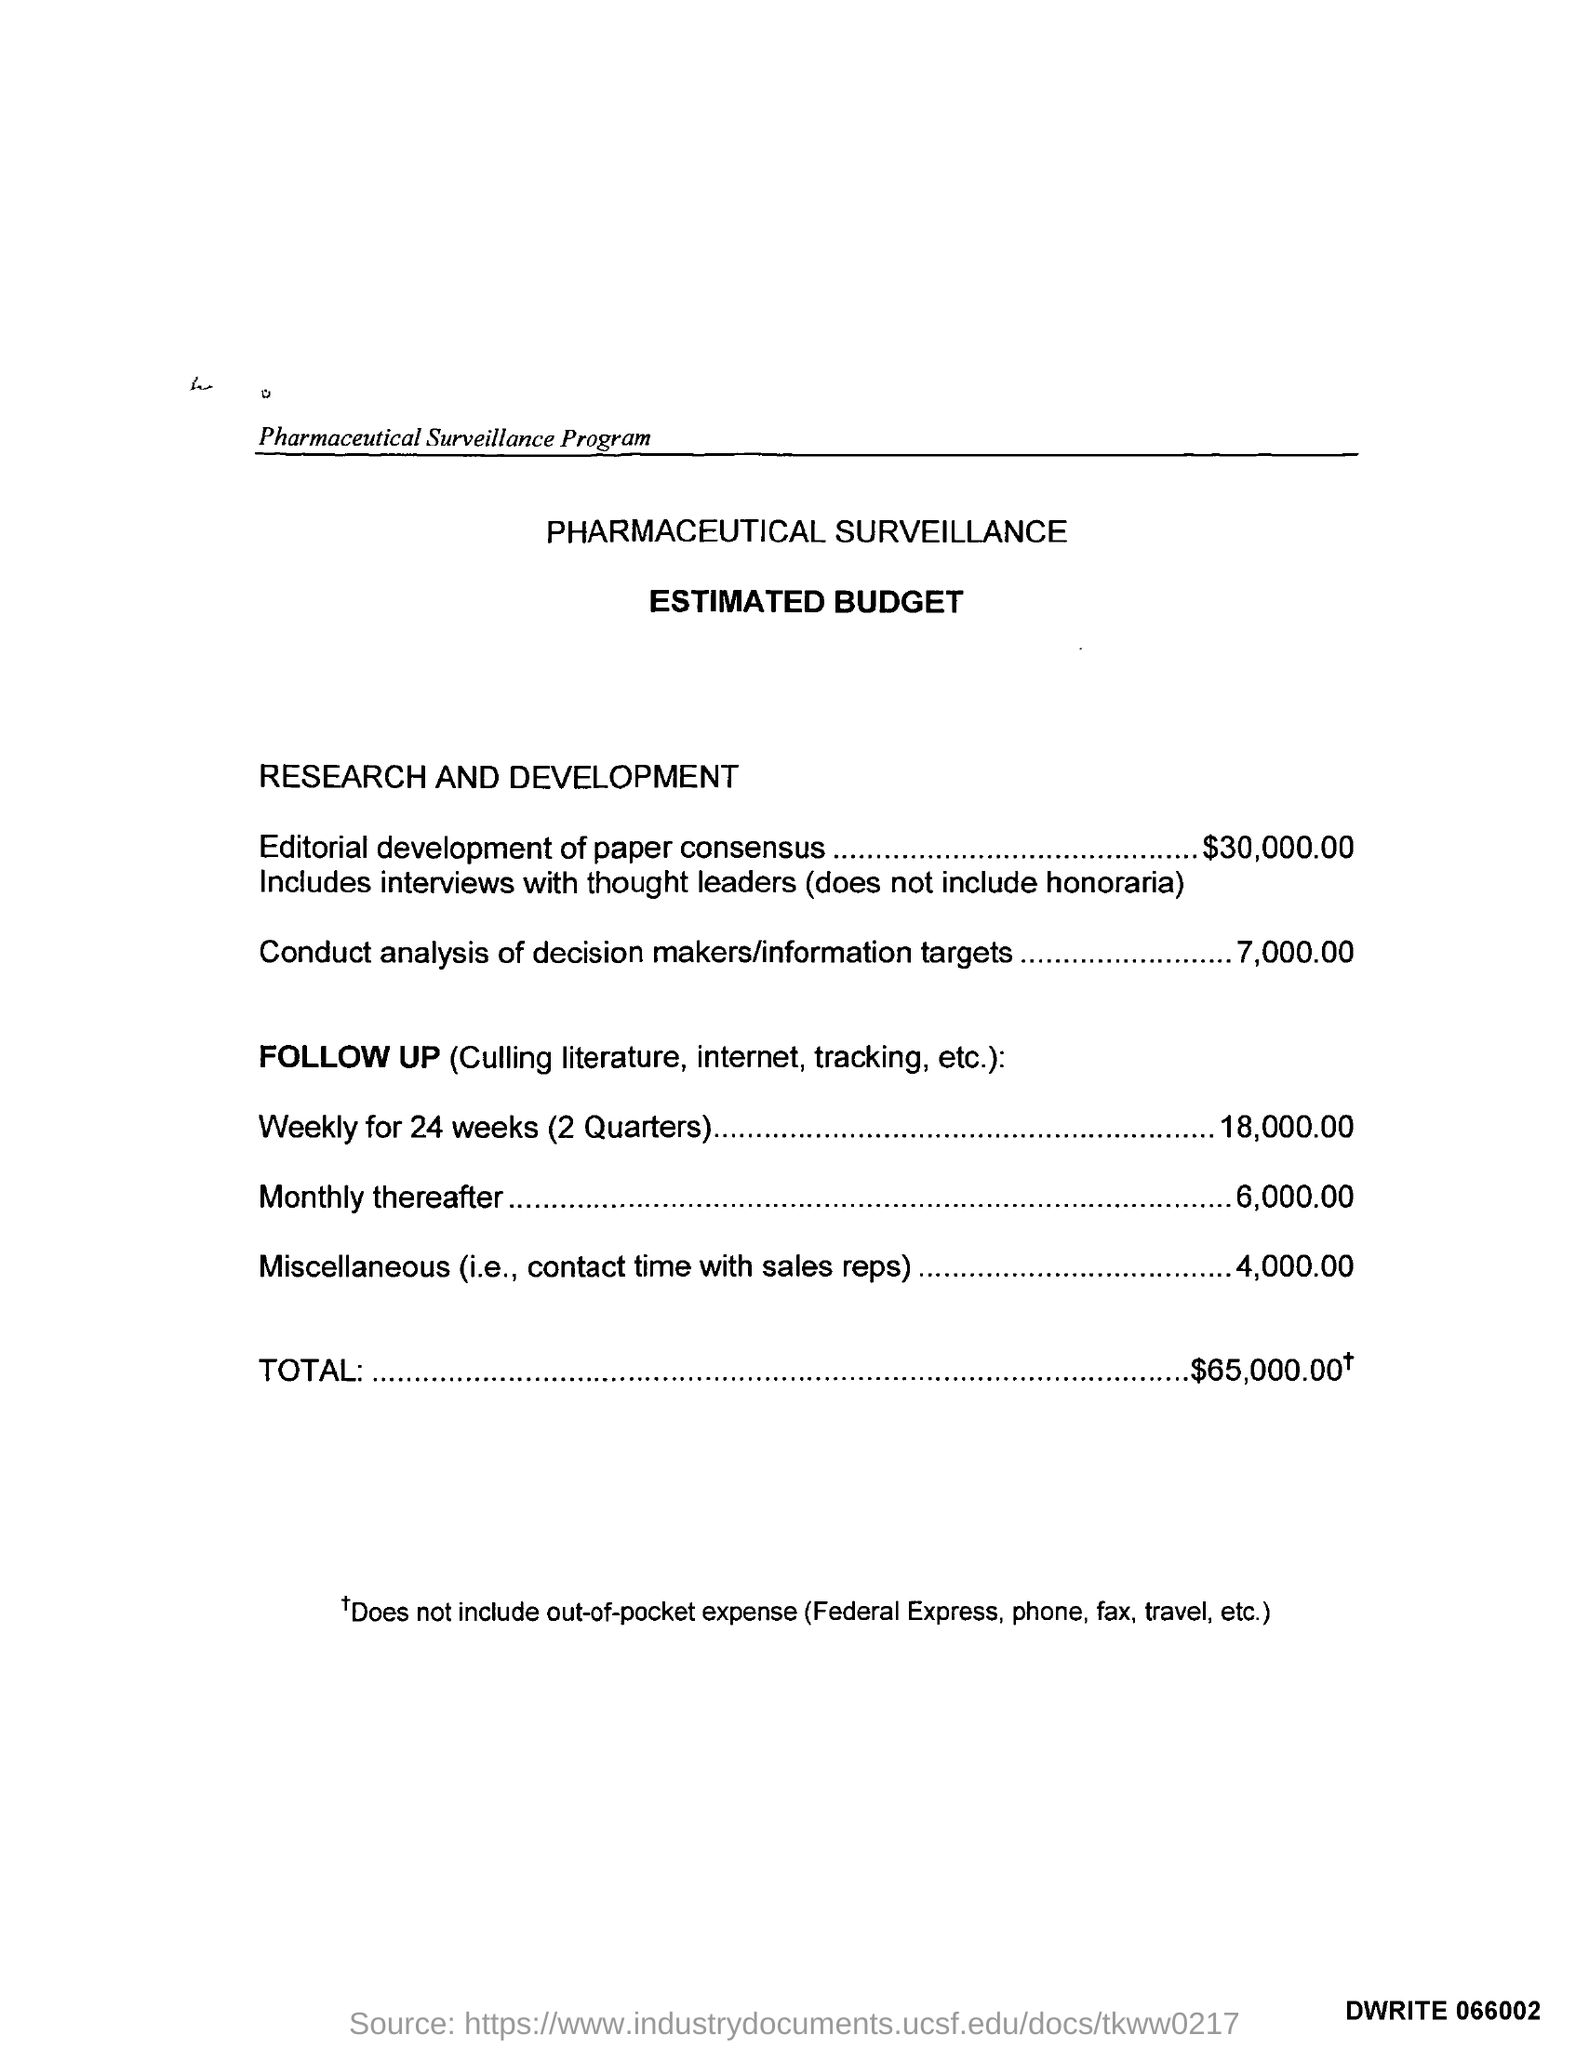what is the estimated budget given for conduct analysis of decision makers/information targets ? The estimated budget allocated for the conduct analysis of decision makers/information targets is $7,000. This is detailed in the 'PHARMACEUTICAL SURVEILLANCE ESTIMATED BUDGET' section under 'RESEARCH AND DEVELOPMENT'. It is a specific cost item mentioned within a larger budget framework designed for pharmaceutical surveillance over a certain period. 